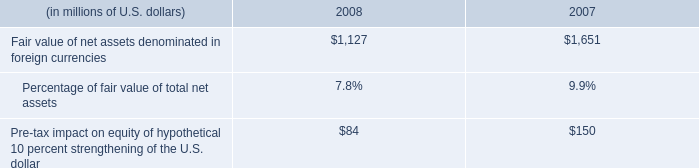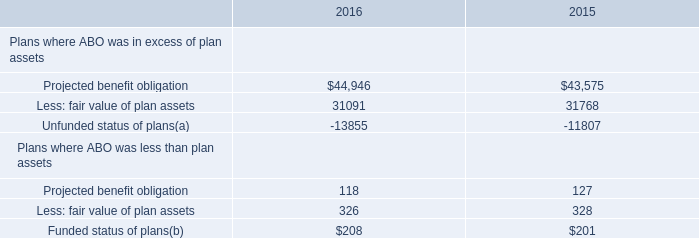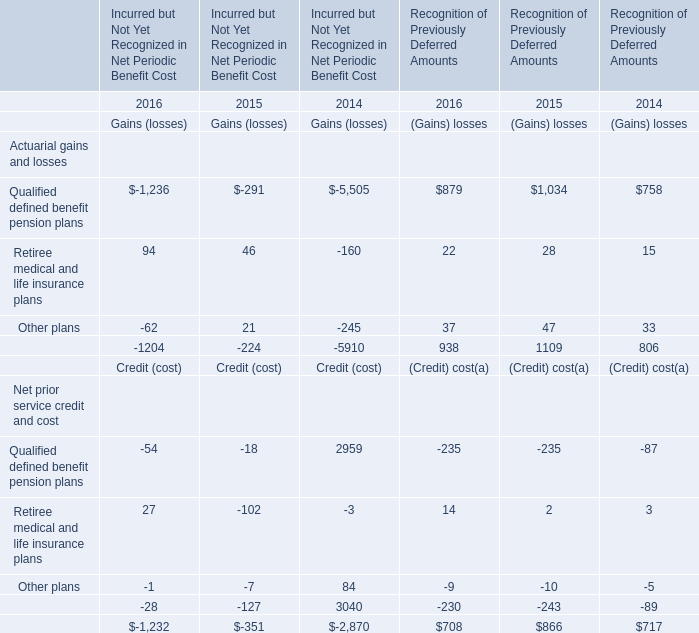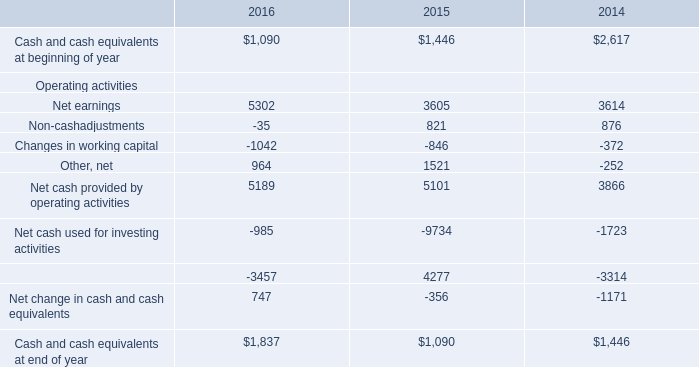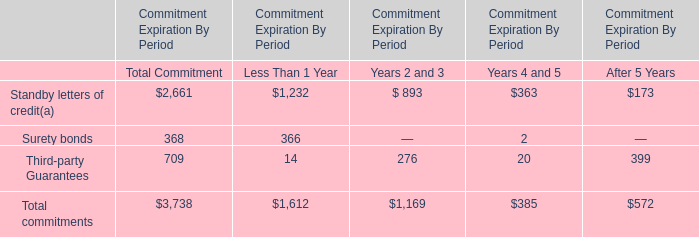What is the average value of Qualified defined benefit pension plans in 2016,2015 and 2014? 
Computations: ((((((-1236 - 291) - 5505) + 879) + 1034) + 758) / 3)
Answer: -1453.66667. 